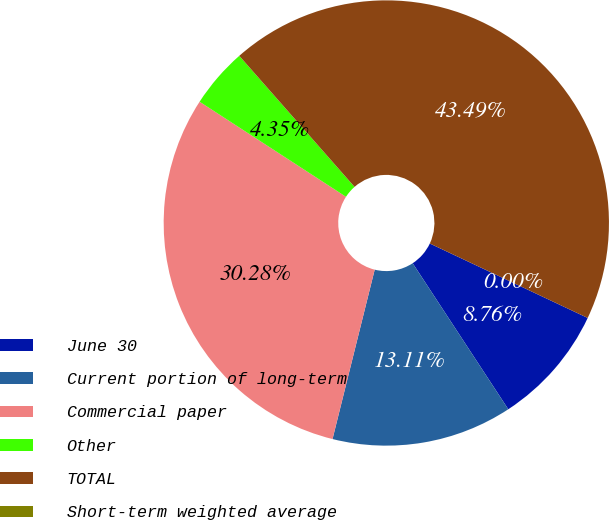Convert chart to OTSL. <chart><loc_0><loc_0><loc_500><loc_500><pie_chart><fcel>June 30<fcel>Current portion of long-term<fcel>Commercial paper<fcel>Other<fcel>TOTAL<fcel>Short-term weighted average<nl><fcel>8.76%<fcel>13.11%<fcel>30.28%<fcel>4.35%<fcel>43.49%<fcel>0.0%<nl></chart> 